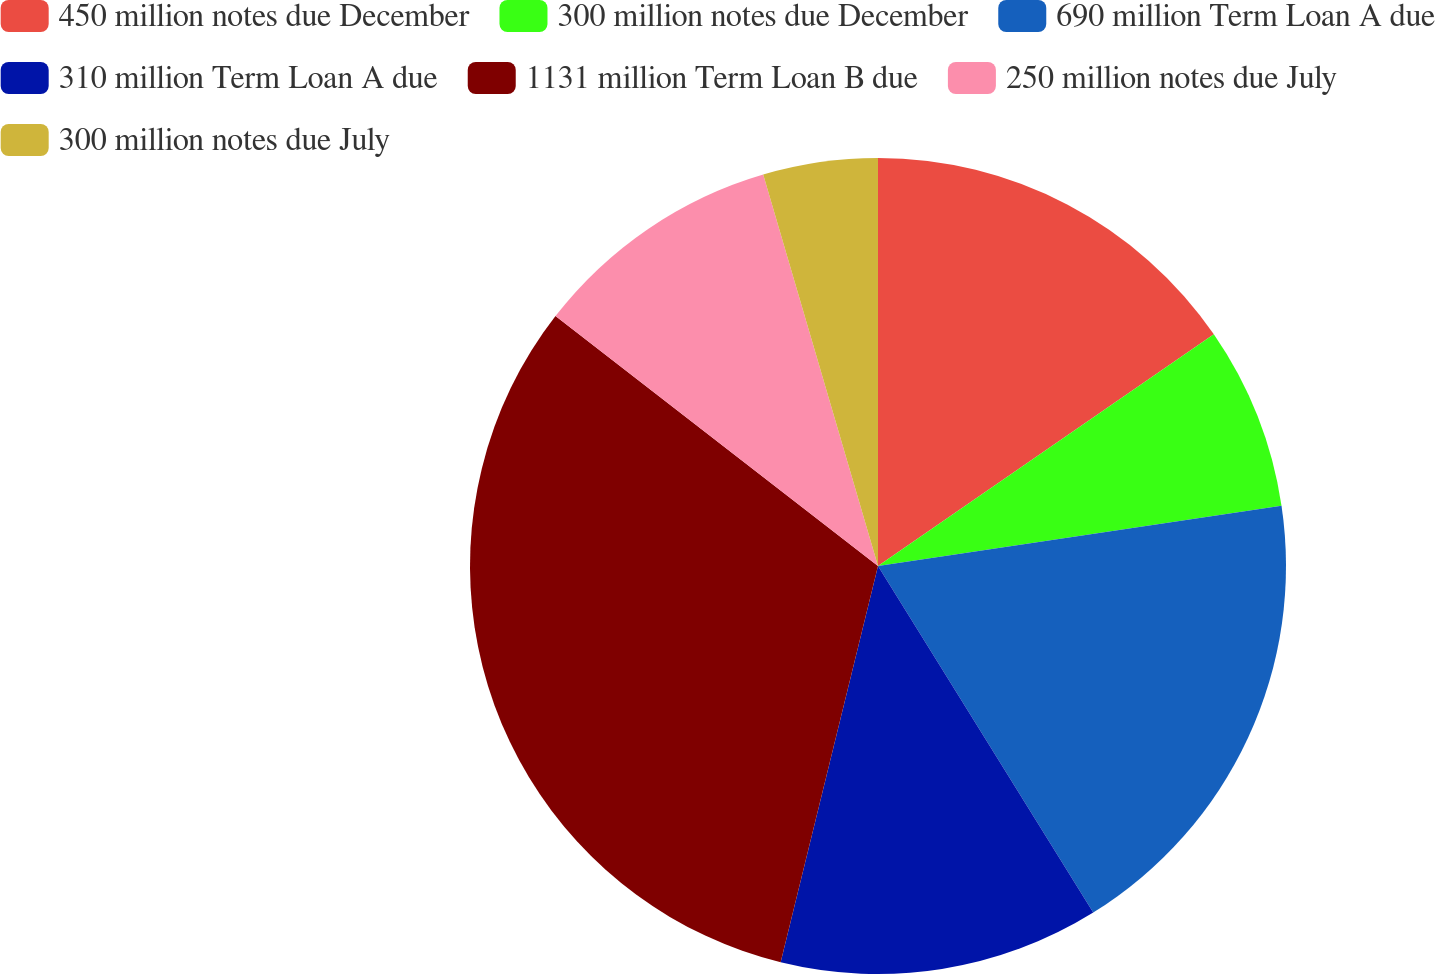Convert chart to OTSL. <chart><loc_0><loc_0><loc_500><loc_500><pie_chart><fcel>450 million notes due December<fcel>300 million notes due December<fcel>690 million Term Loan A due<fcel>310 million Term Loan A due<fcel>1131 million Term Loan B due<fcel>250 million notes due July<fcel>300 million notes due July<nl><fcel>15.39%<fcel>7.25%<fcel>18.52%<fcel>12.68%<fcel>31.66%<fcel>9.97%<fcel>4.54%<nl></chart> 